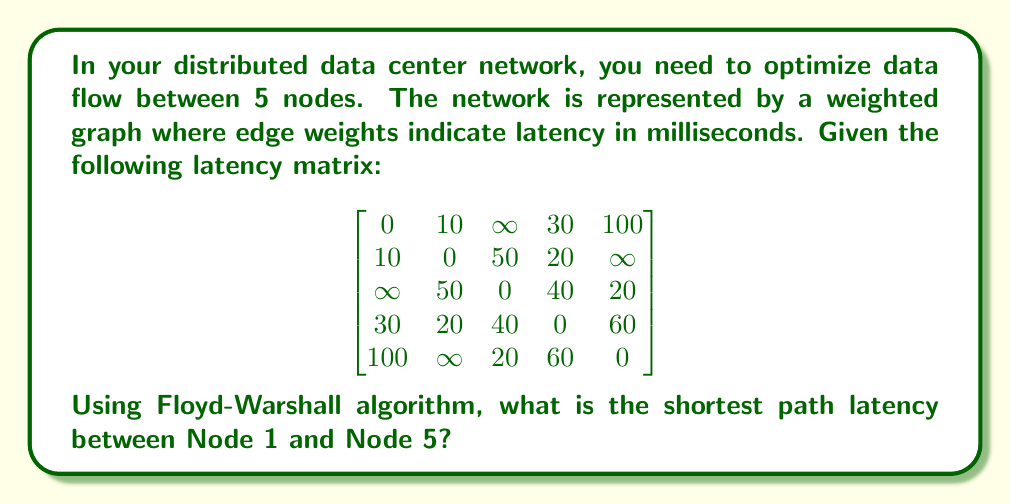Teach me how to tackle this problem. To solve this problem, we'll apply the Floyd-Warshall algorithm to find the shortest paths between all pairs of nodes. This algorithm is particularly useful for distributed systems as it provides a comprehensive view of the network's latency structure.

The Floyd-Warshall algorithm works as follows:

1. Initialize the distance matrix D with the given latency matrix.
2. For each intermediate node k from 1 to 5:
   For each pair of nodes (i, j):
     Update D[i][j] = min(D[i][j], D[i][k] + D[k][j])

Let's go through the iterations:

Initial D matrix:
$$
D^{(0)} = \begin{bmatrix}
0 & 10 & \infty & 30 & 100 \\
10 & 0 & 50 & 20 & \infty \\
\infty & 50 & 0 & 40 & 20 \\
30 & 20 & 40 & 0 & 60 \\
100 & \infty & 20 & 60 & 0
\end{bmatrix}
$$

After considering node 1 as intermediate:
$$
D^{(1)} = \begin{bmatrix}
0 & 10 & \infty & 30 & 100 \\
10 & 0 & 50 & 20 & \infty \\
\infty & 50 & 0 & 40 & 20 \\
30 & 20 & 40 & 0 & 60 \\
100 & \infty & 20 & 60 & 0
\end{bmatrix}
$$

After considering node 2 as intermediate:
$$
D^{(2)} = \begin{bmatrix}
0 & 10 & 60 & 30 & \infty \\
10 & 0 & 50 & 20 & \infty \\
60 & 50 & 0 & 40 & 20 \\
30 & 20 & 40 & 0 & 60 \\
100 & \infty & 20 & 60 & 0
\end{bmatrix}
$$

After considering node 3 as intermediate:
$$
D^{(3)} = \begin{bmatrix}
0 & 10 & 60 & 30 & 80 \\
10 & 0 & 50 & 20 & 70 \\
60 & 50 & 0 & 40 & 20 \\
30 & 20 & 40 & 0 & 60 \\
80 & 70 & 20 & 60 & 0
\end{bmatrix}
$$

After considering node 4 as intermediate:
$$
D^{(4)} = \begin{bmatrix}
0 & 10 & 50 & 30 & 80 \\
10 & 0 & 40 & 20 & 70 \\
50 & 40 & 0 & 40 & 20 \\
30 & 20 & 40 & 0 & 60 \\
80 & 70 & 20 & 60 & 0
\end{bmatrix}
$$

After considering node 5 as intermediate (final matrix):
$$
D^{(5)} = \begin{bmatrix}
0 & 10 & 50 & 30 & 80 \\
10 & 0 & 40 & 20 & 70 \\
50 & 40 & 0 & 40 & 20 \\
30 & 20 & 40 & 0 & 60 \\
80 & 70 & 20 & 60 & 0
\end{bmatrix}
$$

The shortest path latency between Node 1 and Node 5 is found in D[1][5] of the final matrix.
Answer: 80 milliseconds 